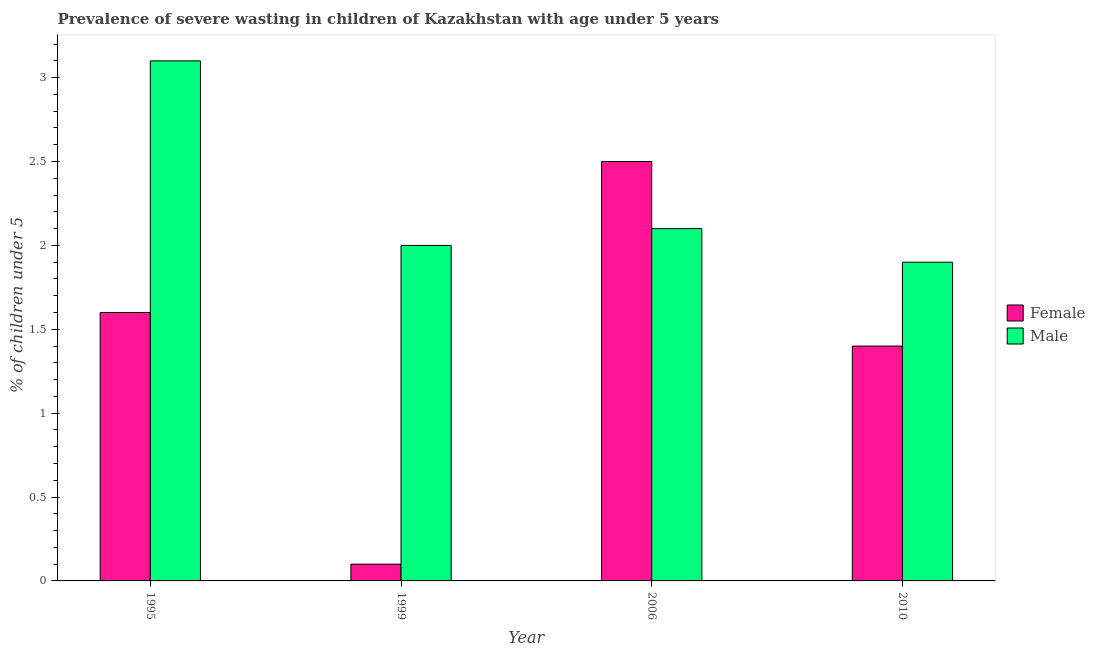Are the number of bars per tick equal to the number of legend labels?
Ensure brevity in your answer.  Yes. Are the number of bars on each tick of the X-axis equal?
Ensure brevity in your answer.  Yes. Across all years, what is the maximum percentage of undernourished female children?
Your response must be concise. 2.5. Across all years, what is the minimum percentage of undernourished male children?
Your answer should be very brief. 1.9. In which year was the percentage of undernourished female children maximum?
Ensure brevity in your answer.  2006. In which year was the percentage of undernourished male children minimum?
Your answer should be compact. 2010. What is the total percentage of undernourished female children in the graph?
Give a very brief answer. 5.6. What is the difference between the percentage of undernourished male children in 1999 and that in 2010?
Provide a short and direct response. 0.1. What is the difference between the percentage of undernourished male children in 2010 and the percentage of undernourished female children in 2006?
Give a very brief answer. -0.2. What is the average percentage of undernourished male children per year?
Provide a succinct answer. 2.27. What is the ratio of the percentage of undernourished female children in 1999 to that in 2010?
Provide a succinct answer. 0.07. What is the difference between the highest and the second highest percentage of undernourished male children?
Make the answer very short. 1. What is the difference between the highest and the lowest percentage of undernourished female children?
Make the answer very short. 2.4. In how many years, is the percentage of undernourished female children greater than the average percentage of undernourished female children taken over all years?
Your answer should be very brief. 2. Does the graph contain grids?
Offer a terse response. No. How many legend labels are there?
Offer a terse response. 2. How are the legend labels stacked?
Keep it short and to the point. Vertical. What is the title of the graph?
Your answer should be very brief. Prevalence of severe wasting in children of Kazakhstan with age under 5 years. Does "Old" appear as one of the legend labels in the graph?
Offer a terse response. No. What is the label or title of the Y-axis?
Provide a succinct answer.  % of children under 5. What is the  % of children under 5 of Female in 1995?
Offer a terse response. 1.6. What is the  % of children under 5 of Male in 1995?
Provide a succinct answer. 3.1. What is the  % of children under 5 in Female in 1999?
Your response must be concise. 0.1. What is the  % of children under 5 of Male in 1999?
Your response must be concise. 2. What is the  % of children under 5 in Male in 2006?
Offer a very short reply. 2.1. What is the  % of children under 5 in Female in 2010?
Provide a short and direct response. 1.4. What is the  % of children under 5 of Male in 2010?
Your answer should be very brief. 1.9. Across all years, what is the maximum  % of children under 5 in Male?
Your answer should be very brief. 3.1. Across all years, what is the minimum  % of children under 5 in Female?
Give a very brief answer. 0.1. Across all years, what is the minimum  % of children under 5 in Male?
Offer a terse response. 1.9. What is the total  % of children under 5 of Female in the graph?
Give a very brief answer. 5.6. What is the total  % of children under 5 in Male in the graph?
Keep it short and to the point. 9.1. What is the difference between the  % of children under 5 in Female in 1995 and that in 1999?
Ensure brevity in your answer.  1.5. What is the difference between the  % of children under 5 in Female in 1995 and that in 2006?
Ensure brevity in your answer.  -0.9. What is the difference between the  % of children under 5 in Female in 1999 and that in 2006?
Make the answer very short. -2.4. What is the difference between the  % of children under 5 of Female in 2006 and that in 2010?
Offer a very short reply. 1.1. What is the difference between the  % of children under 5 of Male in 2006 and that in 2010?
Offer a very short reply. 0.2. What is the difference between the  % of children under 5 of Female in 1995 and the  % of children under 5 of Male in 1999?
Ensure brevity in your answer.  -0.4. What is the difference between the  % of children under 5 of Female in 1995 and the  % of children under 5 of Male in 2006?
Your answer should be very brief. -0.5. What is the difference between the  % of children under 5 in Female in 1999 and the  % of children under 5 in Male in 2006?
Offer a terse response. -2. What is the difference between the  % of children under 5 of Female in 1999 and the  % of children under 5 of Male in 2010?
Give a very brief answer. -1.8. What is the difference between the  % of children under 5 in Female in 2006 and the  % of children under 5 in Male in 2010?
Provide a short and direct response. 0.6. What is the average  % of children under 5 in Female per year?
Make the answer very short. 1.4. What is the average  % of children under 5 of Male per year?
Provide a short and direct response. 2.27. In the year 1995, what is the difference between the  % of children under 5 in Female and  % of children under 5 in Male?
Give a very brief answer. -1.5. In the year 1999, what is the difference between the  % of children under 5 of Female and  % of children under 5 of Male?
Ensure brevity in your answer.  -1.9. In the year 2006, what is the difference between the  % of children under 5 of Female and  % of children under 5 of Male?
Ensure brevity in your answer.  0.4. In the year 2010, what is the difference between the  % of children under 5 of Female and  % of children under 5 of Male?
Your response must be concise. -0.5. What is the ratio of the  % of children under 5 in Male in 1995 to that in 1999?
Your answer should be very brief. 1.55. What is the ratio of the  % of children under 5 of Female in 1995 to that in 2006?
Make the answer very short. 0.64. What is the ratio of the  % of children under 5 in Male in 1995 to that in 2006?
Provide a short and direct response. 1.48. What is the ratio of the  % of children under 5 of Female in 1995 to that in 2010?
Your answer should be compact. 1.14. What is the ratio of the  % of children under 5 in Male in 1995 to that in 2010?
Your response must be concise. 1.63. What is the ratio of the  % of children under 5 in Female in 1999 to that in 2010?
Offer a very short reply. 0.07. What is the ratio of the  % of children under 5 in Male in 1999 to that in 2010?
Your response must be concise. 1.05. What is the ratio of the  % of children under 5 of Female in 2006 to that in 2010?
Your answer should be compact. 1.79. What is the ratio of the  % of children under 5 of Male in 2006 to that in 2010?
Make the answer very short. 1.11. What is the difference between the highest and the second highest  % of children under 5 in Female?
Your answer should be compact. 0.9. What is the difference between the highest and the second highest  % of children under 5 in Male?
Your answer should be very brief. 1. What is the difference between the highest and the lowest  % of children under 5 of Male?
Give a very brief answer. 1.2. 